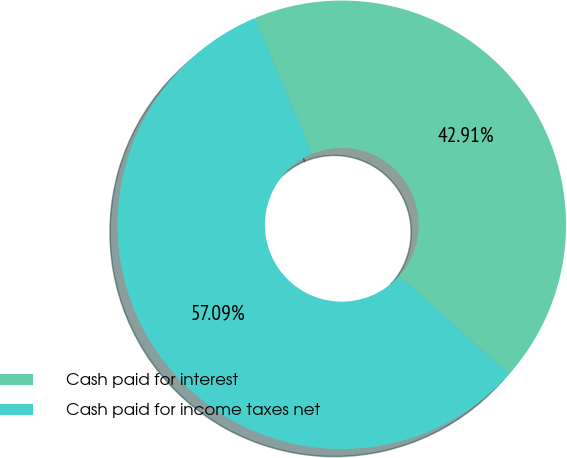Convert chart. <chart><loc_0><loc_0><loc_500><loc_500><pie_chart><fcel>Cash paid for interest<fcel>Cash paid for income taxes net<nl><fcel>42.91%<fcel>57.09%<nl></chart> 